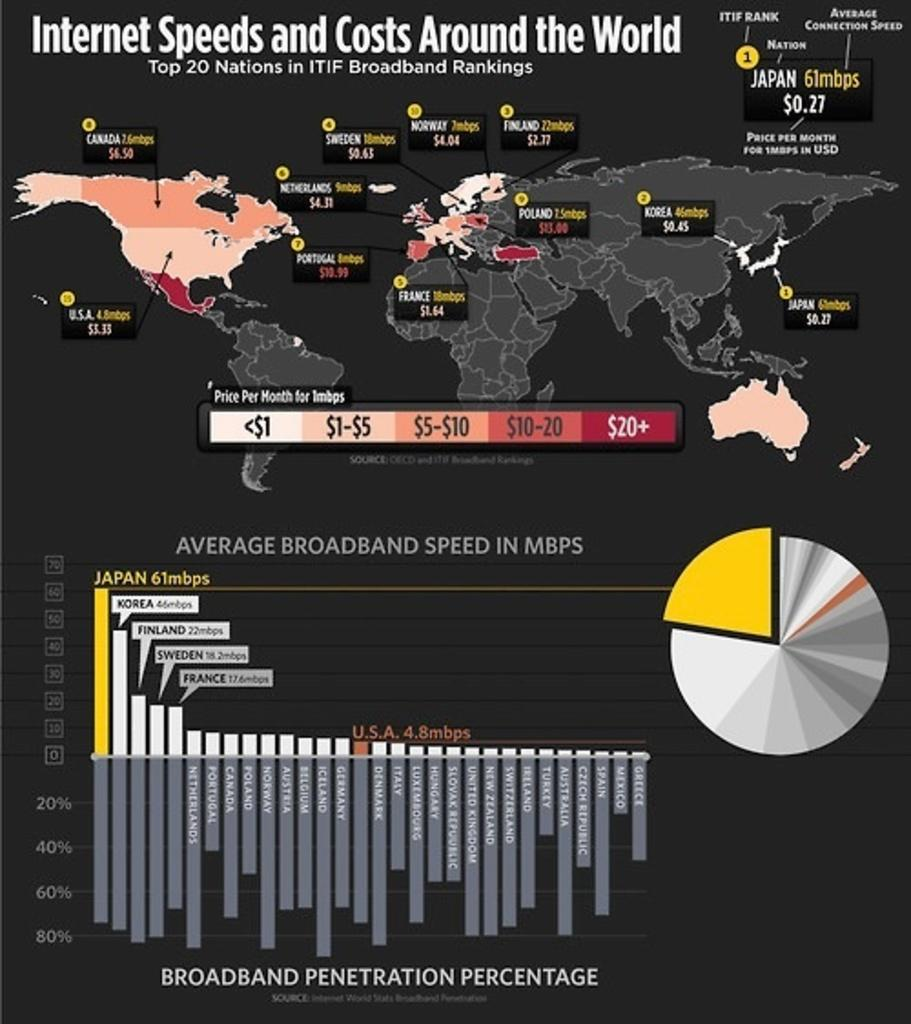<image>
Share a concise interpretation of the image provided. An infographic of internet speeds and costs throughout the world. 